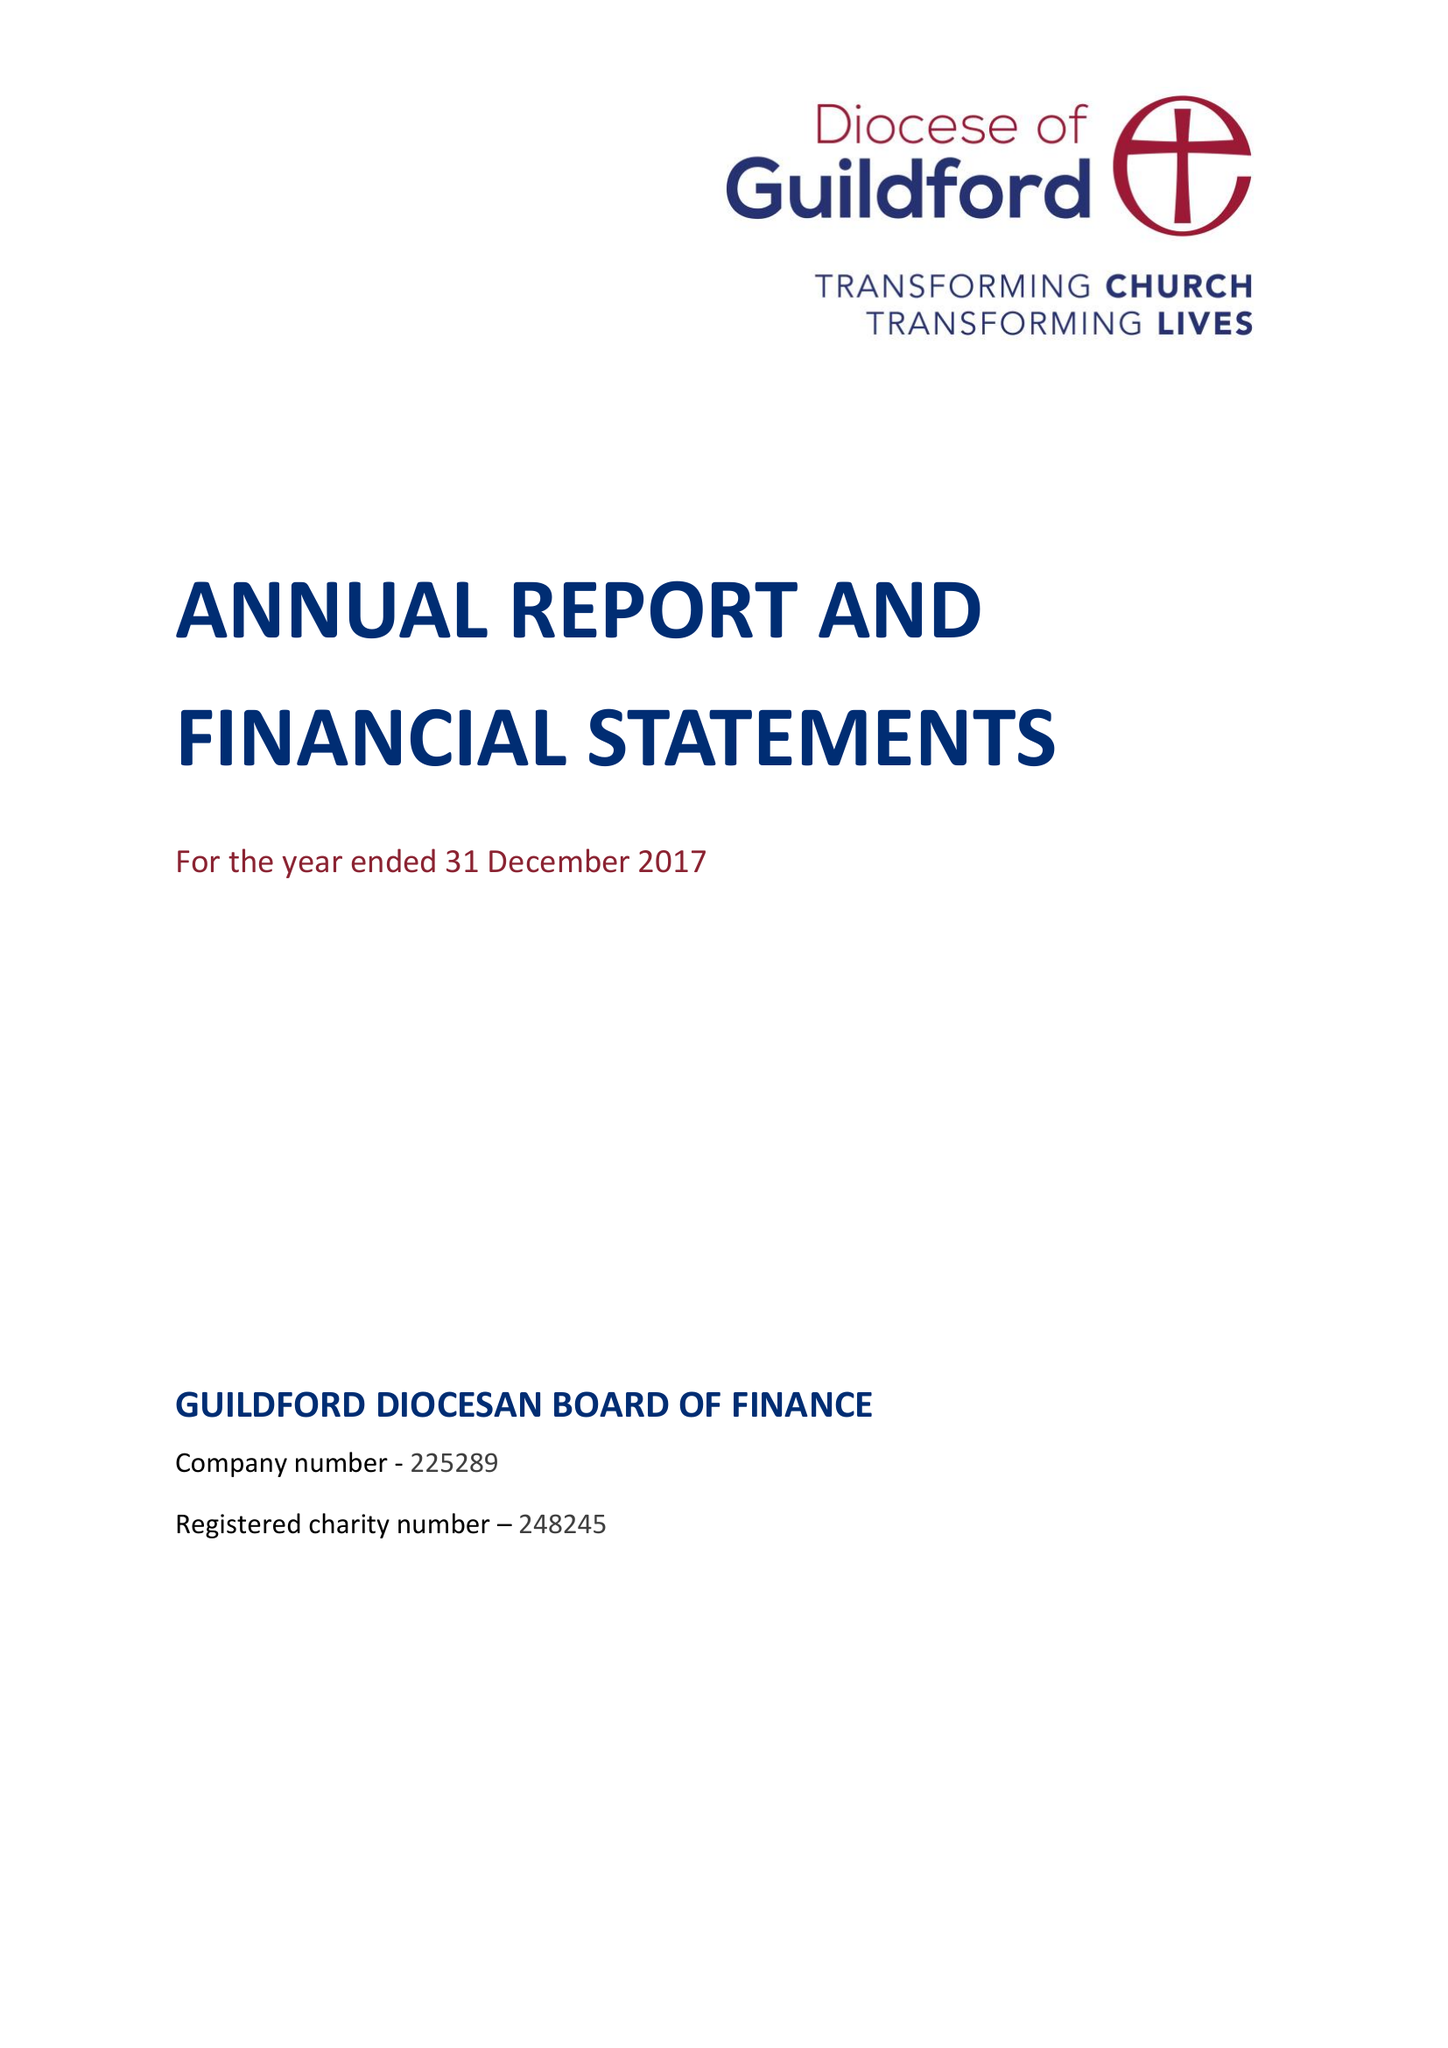What is the value for the charity_number?
Answer the question using a single word or phrase. 248245 